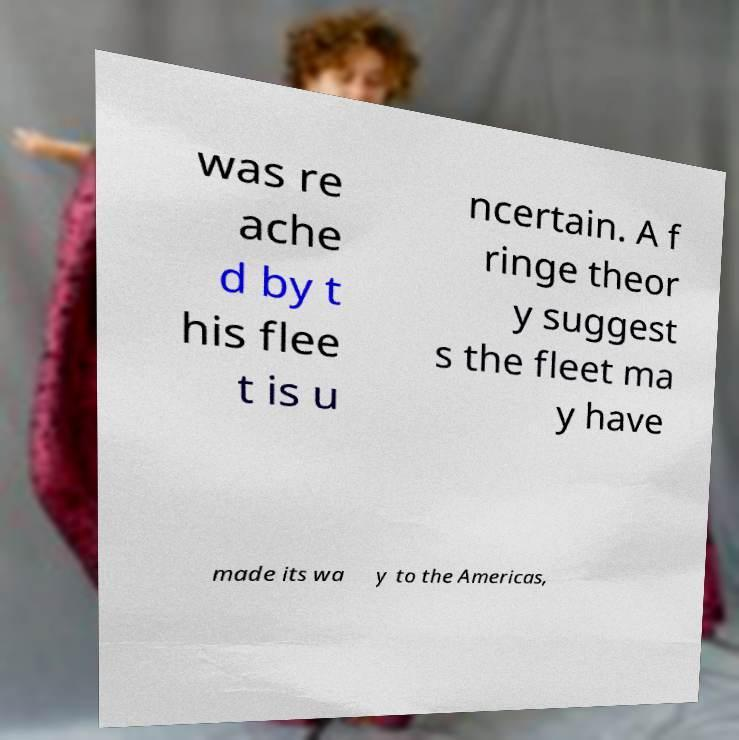Could you extract and type out the text from this image? was re ache d by t his flee t is u ncertain. A f ringe theor y suggest s the fleet ma y have made its wa y to the Americas, 